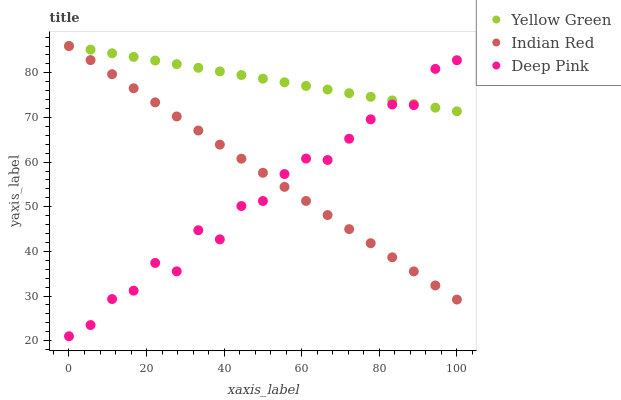Does Deep Pink have the minimum area under the curve?
Answer yes or no. Yes. Does Yellow Green have the maximum area under the curve?
Answer yes or no. Yes. Does Indian Red have the minimum area under the curve?
Answer yes or no. No. Does Indian Red have the maximum area under the curve?
Answer yes or no. No. Is Yellow Green the smoothest?
Answer yes or no. Yes. Is Deep Pink the roughest?
Answer yes or no. Yes. Is Indian Red the smoothest?
Answer yes or no. No. Is Indian Red the roughest?
Answer yes or no. No. Does Deep Pink have the lowest value?
Answer yes or no. Yes. Does Indian Red have the lowest value?
Answer yes or no. No. Does Indian Red have the highest value?
Answer yes or no. Yes. Does Indian Red intersect Deep Pink?
Answer yes or no. Yes. Is Indian Red less than Deep Pink?
Answer yes or no. No. Is Indian Red greater than Deep Pink?
Answer yes or no. No. 